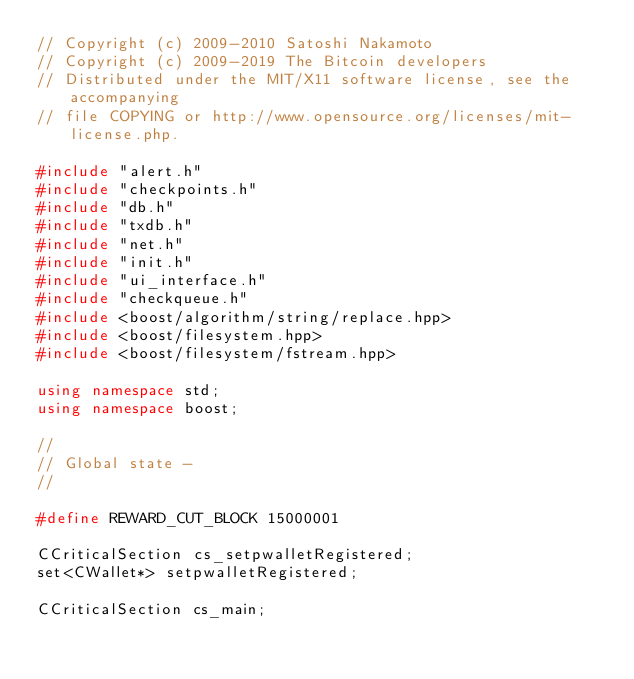Convert code to text. <code><loc_0><loc_0><loc_500><loc_500><_C++_>// Copyright (c) 2009-2010 Satoshi Nakamoto
// Copyright (c) 2009-2019 The Bitcoin developers
// Distributed under the MIT/X11 software license, see the accompanying
// file COPYING or http://www.opensource.org/licenses/mit-license.php.

#include "alert.h"
#include "checkpoints.h"
#include "db.h"
#include "txdb.h"
#include "net.h"
#include "init.h"
#include "ui_interface.h"
#include "checkqueue.h"
#include <boost/algorithm/string/replace.hpp>
#include <boost/filesystem.hpp>
#include <boost/filesystem/fstream.hpp>

using namespace std;
using namespace boost;

//
// Global state -
//

#define REWARD_CUT_BLOCK 15000001

CCriticalSection cs_setpwalletRegistered;
set<CWallet*> setpwalletRegistered;

CCriticalSection cs_main;
</code> 